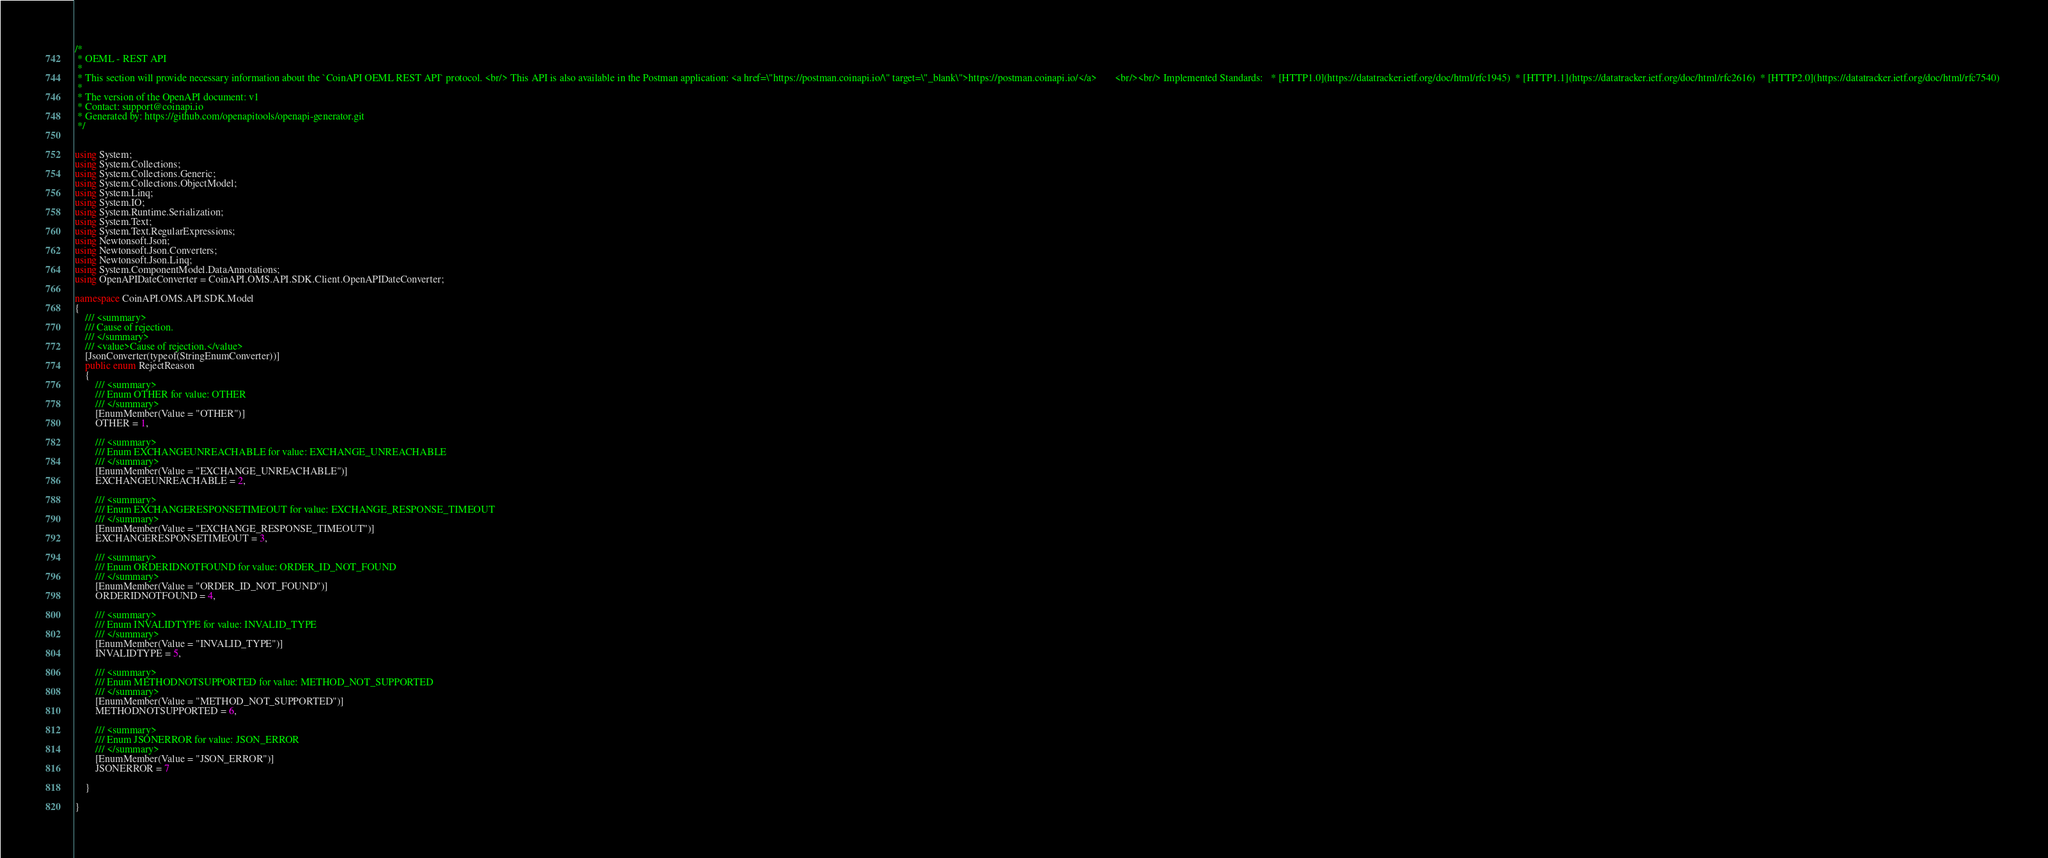Convert code to text. <code><loc_0><loc_0><loc_500><loc_500><_C#_>/*
 * OEML - REST API
 *
 * This section will provide necessary information about the `CoinAPI OEML REST API` protocol. <br/> This API is also available in the Postman application: <a href=\"https://postman.coinapi.io/\" target=\"_blank\">https://postman.coinapi.io/</a>       <br/><br/> Implemented Standards:   * [HTTP1.0](https://datatracker.ietf.org/doc/html/rfc1945)  * [HTTP1.1](https://datatracker.ietf.org/doc/html/rfc2616)  * [HTTP2.0](https://datatracker.ietf.org/doc/html/rfc7540) 
 *
 * The version of the OpenAPI document: v1
 * Contact: support@coinapi.io
 * Generated by: https://github.com/openapitools/openapi-generator.git
 */


using System;
using System.Collections;
using System.Collections.Generic;
using System.Collections.ObjectModel;
using System.Linq;
using System.IO;
using System.Runtime.Serialization;
using System.Text;
using System.Text.RegularExpressions;
using Newtonsoft.Json;
using Newtonsoft.Json.Converters;
using Newtonsoft.Json.Linq;
using System.ComponentModel.DataAnnotations;
using OpenAPIDateConverter = CoinAPI.OMS.API.SDK.Client.OpenAPIDateConverter;

namespace CoinAPI.OMS.API.SDK.Model
{
    /// <summary>
    /// Cause of rejection.
    /// </summary>
    /// <value>Cause of rejection.</value>
    [JsonConverter(typeof(StringEnumConverter))]
    public enum RejectReason
    {
        /// <summary>
        /// Enum OTHER for value: OTHER
        /// </summary>
        [EnumMember(Value = "OTHER")]
        OTHER = 1,

        /// <summary>
        /// Enum EXCHANGEUNREACHABLE for value: EXCHANGE_UNREACHABLE
        /// </summary>
        [EnumMember(Value = "EXCHANGE_UNREACHABLE")]
        EXCHANGEUNREACHABLE = 2,

        /// <summary>
        /// Enum EXCHANGERESPONSETIMEOUT for value: EXCHANGE_RESPONSE_TIMEOUT
        /// </summary>
        [EnumMember(Value = "EXCHANGE_RESPONSE_TIMEOUT")]
        EXCHANGERESPONSETIMEOUT = 3,

        /// <summary>
        /// Enum ORDERIDNOTFOUND for value: ORDER_ID_NOT_FOUND
        /// </summary>
        [EnumMember(Value = "ORDER_ID_NOT_FOUND")]
        ORDERIDNOTFOUND = 4,

        /// <summary>
        /// Enum INVALIDTYPE for value: INVALID_TYPE
        /// </summary>
        [EnumMember(Value = "INVALID_TYPE")]
        INVALIDTYPE = 5,

        /// <summary>
        /// Enum METHODNOTSUPPORTED for value: METHOD_NOT_SUPPORTED
        /// </summary>
        [EnumMember(Value = "METHOD_NOT_SUPPORTED")]
        METHODNOTSUPPORTED = 6,

        /// <summary>
        /// Enum JSONERROR for value: JSON_ERROR
        /// </summary>
        [EnumMember(Value = "JSON_ERROR")]
        JSONERROR = 7

    }

}
</code> 